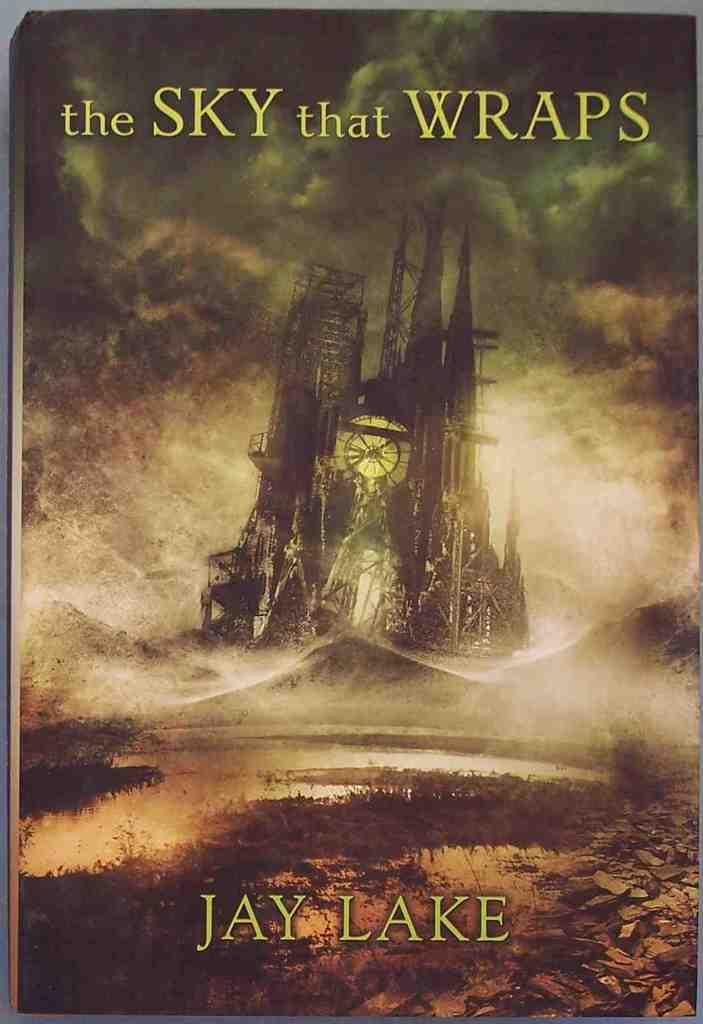Provide a one-sentence caption for the provided image. A book with the title The Sky that Warps by Jay Lake with a picture of an haunting looking sky with a standing structure with a clock displayed. 